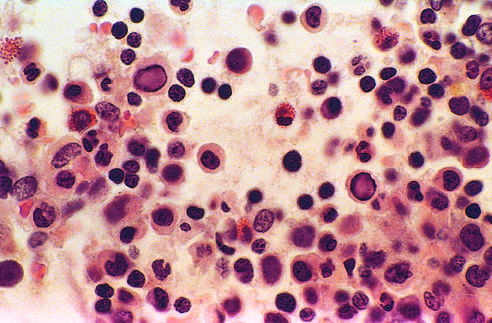what is bone marrow from an infant infected with?
Answer the question using a single word or phrase. Parvovirus b19 